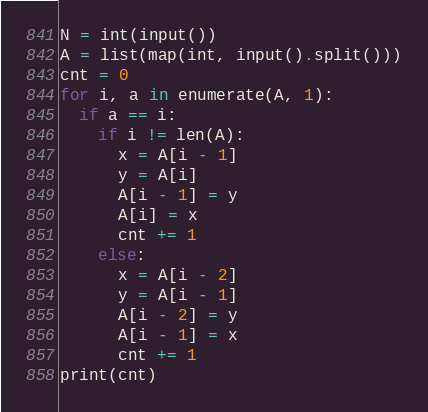<code> <loc_0><loc_0><loc_500><loc_500><_Python_>N = int(input())
A = list(map(int, input().split()))
cnt = 0
for i, a in enumerate(A, 1):
  if a == i:
    if i != len(A):
      x = A[i - 1]
      y = A[i]
      A[i - 1] = y
      A[i] = x    
      cnt += 1
    else:
      x = A[i - 2]
      y = A[i - 1]
      A[i - 2] = y
      A[i - 1] = x    
      cnt += 1
print(cnt)</code> 